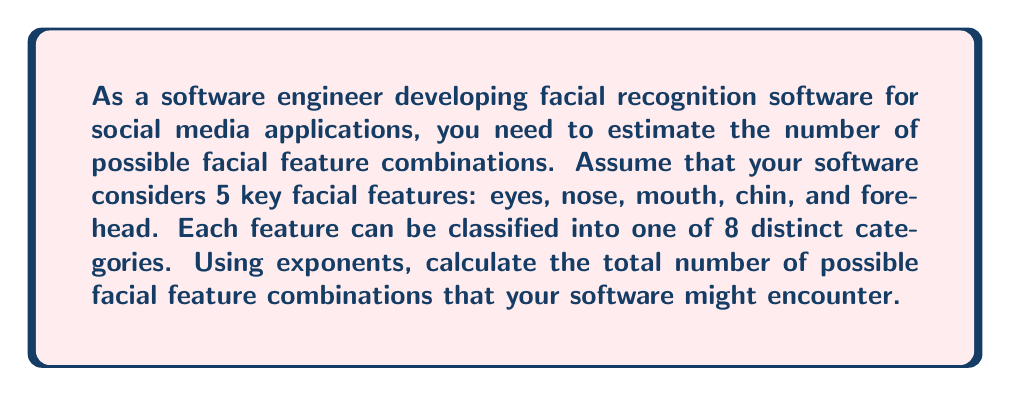Can you solve this math problem? To solve this problem, we need to use the multiplication principle of counting and express it using exponents. Here's the step-by-step explanation:

1. Identify the number of features: 5 (eyes, nose, mouth, chin, and forehead)
2. Identify the number of categories for each feature: 8

3. For each feature, we have 8 choices. As we are considering all 5 features independently, we multiply the number of choices for each feature:

   $8 \times 8 \times 8 \times 8 \times 8$

4. This can be expressed as an exponent:

   $8^5$

5. Calculate the result:
   
   $8^5 = 8 \times 8 \times 8 \times 8 \times 8 = 32,768$

Therefore, the total number of possible facial feature combinations that your software might encounter is 32,768.
Answer: $8^5 = 32,768$ possible facial feature combinations 